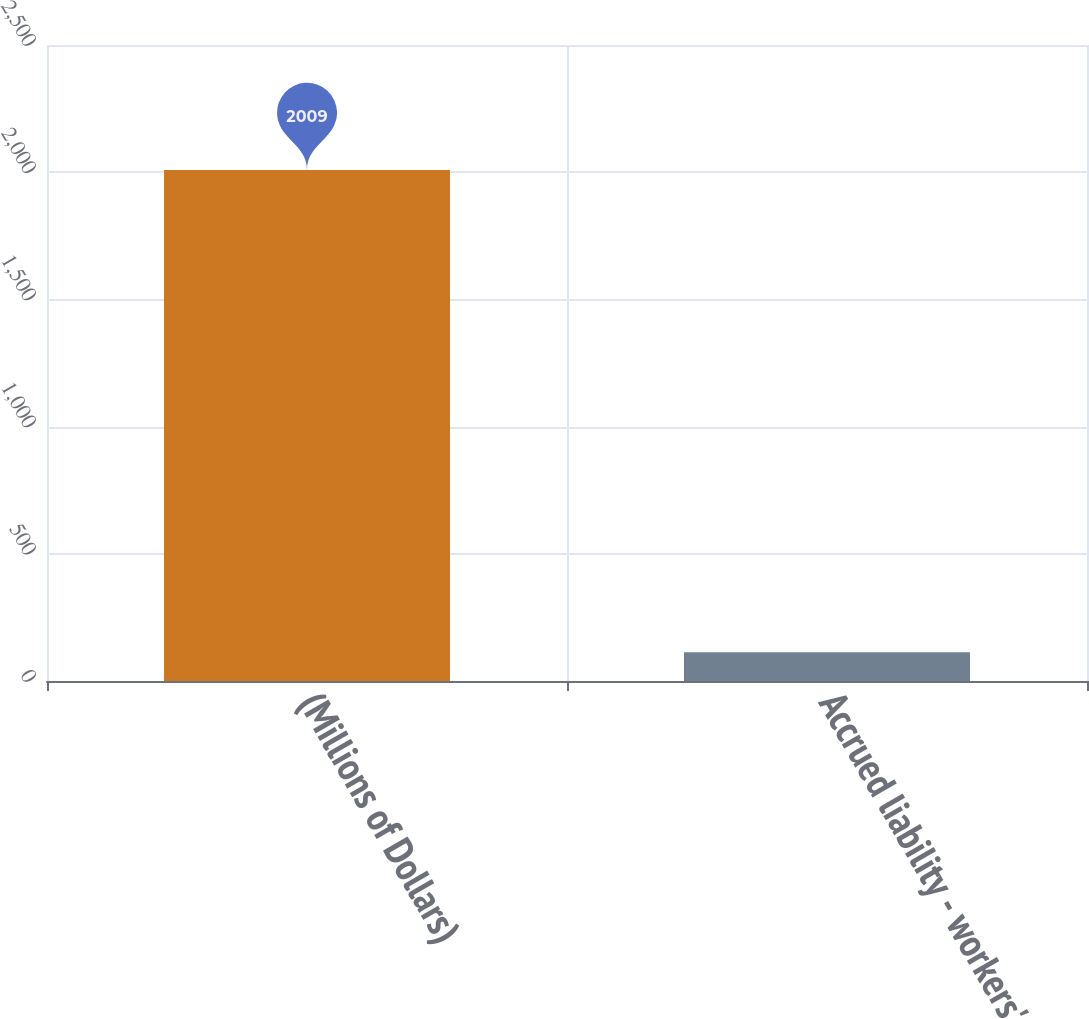Convert chart to OTSL. <chart><loc_0><loc_0><loc_500><loc_500><bar_chart><fcel>(Millions of Dollars)<fcel>Accrued liability - workers'<nl><fcel>2009<fcel>113<nl></chart> 